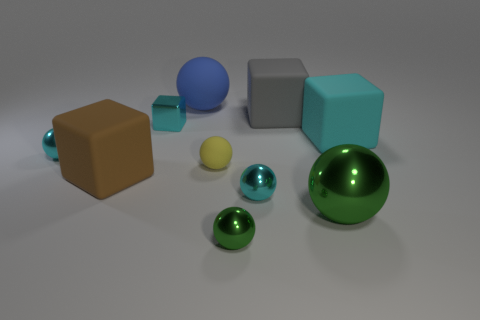Subtract all green balls. How many balls are left? 4 Subtract all large spheres. How many spheres are left? 4 Subtract all red balls. Subtract all red blocks. How many balls are left? 6 Subtract all blocks. How many objects are left? 6 Add 5 red rubber cylinders. How many red rubber cylinders exist? 5 Subtract 0 yellow blocks. How many objects are left? 10 Subtract all blue objects. Subtract all large matte spheres. How many objects are left? 8 Add 2 large blue rubber things. How many large blue rubber things are left? 3 